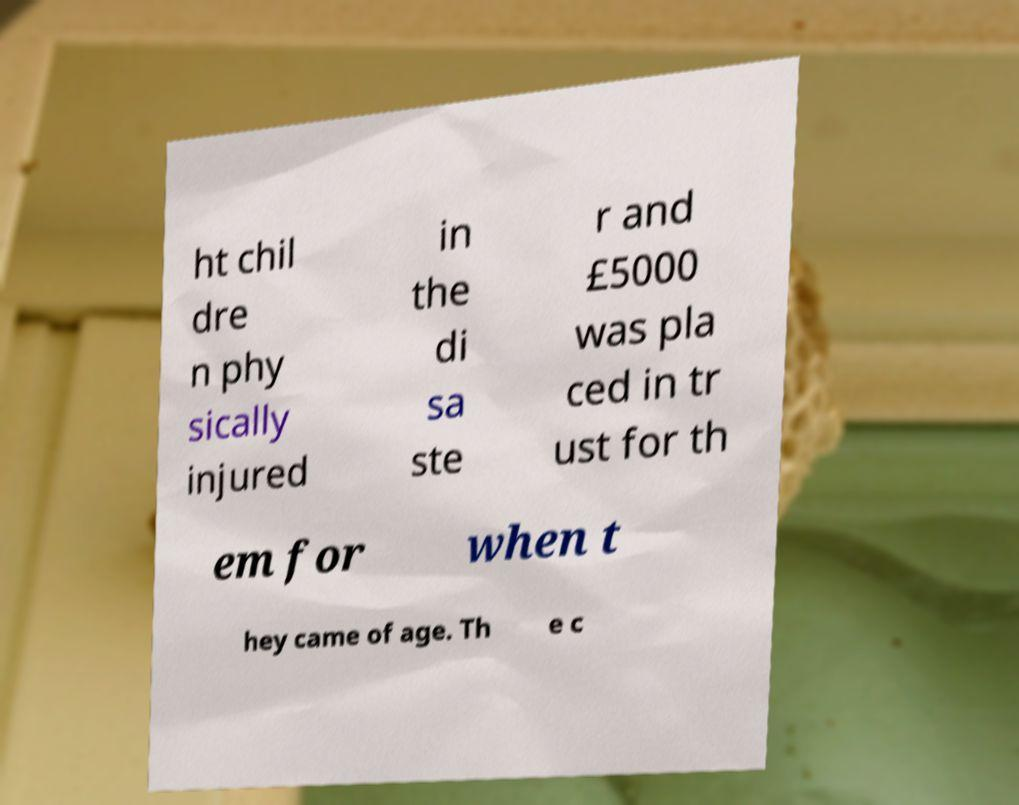What messages or text are displayed in this image? I need them in a readable, typed format. ht chil dre n phy sically injured in the di sa ste r and £5000 was pla ced in tr ust for th em for when t hey came of age. Th e c 